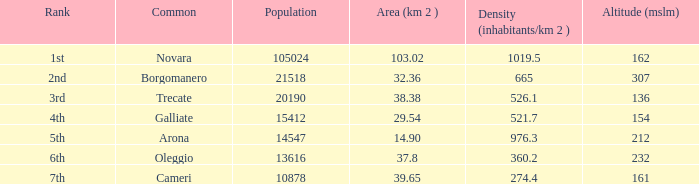Which common occupies a space (km2) of 3 Trecate. 